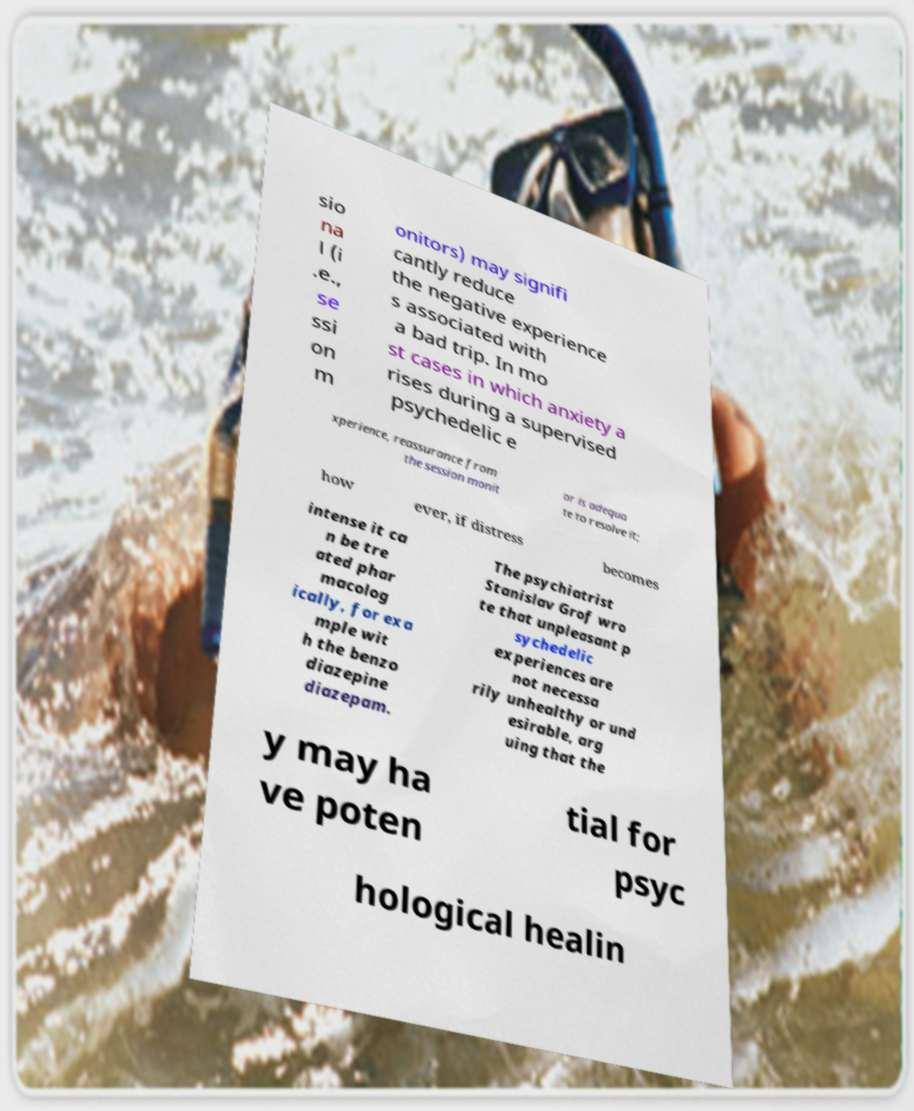Can you accurately transcribe the text from the provided image for me? sio na l (i .e., se ssi on m onitors) may signifi cantly reduce the negative experience s associated with a bad trip. In mo st cases in which anxiety a rises during a supervised psychedelic e xperience, reassurance from the session monit or is adequa te to resolve it; how ever, if distress becomes intense it ca n be tre ated phar macolog ically, for exa mple wit h the benzo diazepine diazepam. The psychiatrist Stanislav Grof wro te that unpleasant p sychedelic experiences are not necessa rily unhealthy or und esirable, arg uing that the y may ha ve poten tial for psyc hological healin 